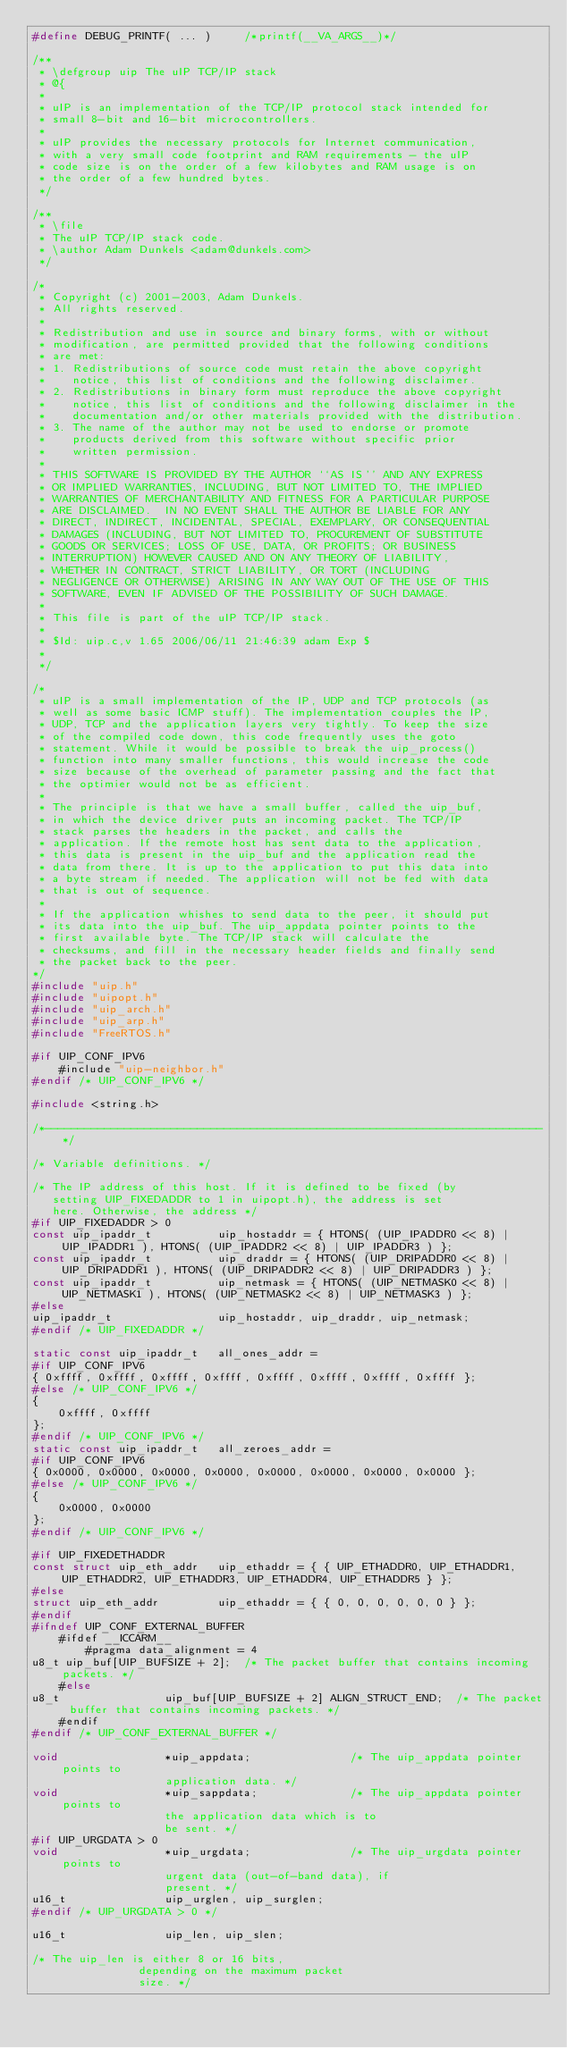Convert code to text. <code><loc_0><loc_0><loc_500><loc_500><_C_>#define DEBUG_PRINTF( ... )		/*printf(__VA_ARGS__)*/

/**
 * \defgroup uip The uIP TCP/IP stack
 * @{
 *
 * uIP is an implementation of the TCP/IP protocol stack intended for
 * small 8-bit and 16-bit microcontrollers.
 *
 * uIP provides the necessary protocols for Internet communication,
 * with a very small code footprint and RAM requirements - the uIP
 * code size is on the order of a few kilobytes and RAM usage is on
 * the order of a few hundred bytes.
 */

/**
 * \file
 * The uIP TCP/IP stack code.
 * \author Adam Dunkels <adam@dunkels.com>
 */

/*
 * Copyright (c) 2001-2003, Adam Dunkels.
 * All rights reserved.
 *
 * Redistribution and use in source and binary forms, with or without
 * modification, are permitted provided that the following conditions
 * are met:
 * 1. Redistributions of source code must retain the above copyright
 *    notice, this list of conditions and the following disclaimer.
 * 2. Redistributions in binary form must reproduce the above copyright
 *    notice, this list of conditions and the following disclaimer in the
 *    documentation and/or other materials provided with the distribution.
 * 3. The name of the author may not be used to endorse or promote
 *    products derived from this software without specific prior
 *    written permission.
 *
 * THIS SOFTWARE IS PROVIDED BY THE AUTHOR ``AS IS'' AND ANY EXPRESS
 * OR IMPLIED WARRANTIES, INCLUDING, BUT NOT LIMITED TO, THE IMPLIED
 * WARRANTIES OF MERCHANTABILITY AND FITNESS FOR A PARTICULAR PURPOSE
 * ARE DISCLAIMED.  IN NO EVENT SHALL THE AUTHOR BE LIABLE FOR ANY
 * DIRECT, INDIRECT, INCIDENTAL, SPECIAL, EXEMPLARY, OR CONSEQUENTIAL
 * DAMAGES (INCLUDING, BUT NOT LIMITED TO, PROCUREMENT OF SUBSTITUTE
 * GOODS OR SERVICES; LOSS OF USE, DATA, OR PROFITS; OR BUSINESS
 * INTERRUPTION) HOWEVER CAUSED AND ON ANY THEORY OF LIABILITY,
 * WHETHER IN CONTRACT, STRICT LIABILITY, OR TORT (INCLUDING
 * NEGLIGENCE OR OTHERWISE) ARISING IN ANY WAY OUT OF THE USE OF THIS
 * SOFTWARE, EVEN IF ADVISED OF THE POSSIBILITY OF SUCH DAMAGE.
 *
 * This file is part of the uIP TCP/IP stack.
 *
 * $Id: uip.c,v 1.65 2006/06/11 21:46:39 adam Exp $
 *
 */

/*
 * uIP is a small implementation of the IP, UDP and TCP protocols (as
 * well as some basic ICMP stuff). The implementation couples the IP,
 * UDP, TCP and the application layers very tightly. To keep the size
 * of the compiled code down, this code frequently uses the goto
 * statement. While it would be possible to break the uip_process()
 * function into many smaller functions, this would increase the code
 * size because of the overhead of parameter passing and the fact that
 * the optimier would not be as efficient.
 *
 * The principle is that we have a small buffer, called the uip_buf,
 * in which the device driver puts an incoming packet. The TCP/IP
 * stack parses the headers in the packet, and calls the
 * application. If the remote host has sent data to the application,
 * this data is present in the uip_buf and the application read the
 * data from there. It is up to the application to put this data into
 * a byte stream if needed. The application will not be fed with data
 * that is out of sequence.
 *
 * If the application whishes to send data to the peer, it should put
 * its data into the uip_buf. The uip_appdata pointer points to the
 * first available byte. The TCP/IP stack will calculate the
 * checksums, and fill in the necessary header fields and finally send
 * the packet back to the peer.
*/
#include "uip.h"
#include "uipopt.h"
#include "uip_arch.h"
#include "uip_arp.h"
#include "FreeRTOS.h"

#if UIP_CONF_IPV6
	#include "uip-neighbor.h"
#endif /* UIP_CONF_IPV6 */

#include <string.h>

/*---------------------------------------------------------------------------*/

/* Variable definitions. */

/* The IP address of this host. If it is defined to be fixed (by
   setting UIP_FIXEDADDR to 1 in uipopt.h), the address is set
   here. Otherwise, the address */
#if UIP_FIXEDADDR > 0
const uip_ipaddr_t			uip_hostaddr = { HTONS( (UIP_IPADDR0 << 8) | UIP_IPADDR1 ), HTONS( (UIP_IPADDR2 << 8) | UIP_IPADDR3 ) };
const uip_ipaddr_t			uip_draddr = { HTONS( (UIP_DRIPADDR0 << 8) | UIP_DRIPADDR1 ), HTONS( (UIP_DRIPADDR2 << 8) | UIP_DRIPADDR3 ) };
const uip_ipaddr_t			uip_netmask = { HTONS( (UIP_NETMASK0 << 8) | UIP_NETMASK1 ), HTONS( (UIP_NETMASK2 << 8) | UIP_NETMASK3 ) };
#else
uip_ipaddr_t				uip_hostaddr, uip_draddr, uip_netmask;
#endif /* UIP_FIXEDADDR */

static const uip_ipaddr_t	all_ones_addr =
#if UIP_CONF_IPV6
{ 0xffff, 0xffff, 0xffff, 0xffff, 0xffff, 0xffff, 0xffff, 0xffff };
#else /* UIP_CONF_IPV6 */
{
	0xffff, 0xffff
};
#endif /* UIP_CONF_IPV6 */
static const uip_ipaddr_t	all_zeroes_addr =
#if UIP_CONF_IPV6
{ 0x0000, 0x0000, 0x0000, 0x0000, 0x0000, 0x0000, 0x0000, 0x0000 };
#else /* UIP_CONF_IPV6 */
{
	0x0000, 0x0000
};
#endif /* UIP_CONF_IPV6 */

#if UIP_FIXEDETHADDR
const struct uip_eth_addr	uip_ethaddr = { { UIP_ETHADDR0, UIP_ETHADDR1, UIP_ETHADDR2, UIP_ETHADDR3, UIP_ETHADDR4, UIP_ETHADDR5 } };
#else
struct uip_eth_addr			uip_ethaddr = { { 0, 0, 0, 0, 0, 0 } };
#endif
#ifndef UIP_CONF_EXTERNAL_BUFFER
	#ifdef __ICCARM__
		#pragma data_alignment = 4
u8_t uip_buf[UIP_BUFSIZE + 2];	/* The packet buffer that contains incoming packets. */
	#else
u8_t				uip_buf[UIP_BUFSIZE + 2] ALIGN_STRUCT_END;	/* The packet buffer that contains incoming packets. */
	#endif
#endif /* UIP_CONF_EXTERNAL_BUFFER */

void				*uip_appdata;				/* The uip_appdata pointer points to
				    application data. */
void				*uip_sappdata;				/* The uip_appdata pointer points to
				    the application data which is to
				    be sent. */
#if UIP_URGDATA > 0
void				*uip_urgdata;				/* The uip_urgdata pointer points to
   				    urgent data (out-of-band data), if
   				    present. */
u16_t				uip_urglen, uip_surglen;
#endif /* UIP_URGDATA > 0 */

u16_t				uip_len, uip_slen;

/* The uip_len is either 8 or 16 bits,
				depending on the maximum packet
				size. */</code> 